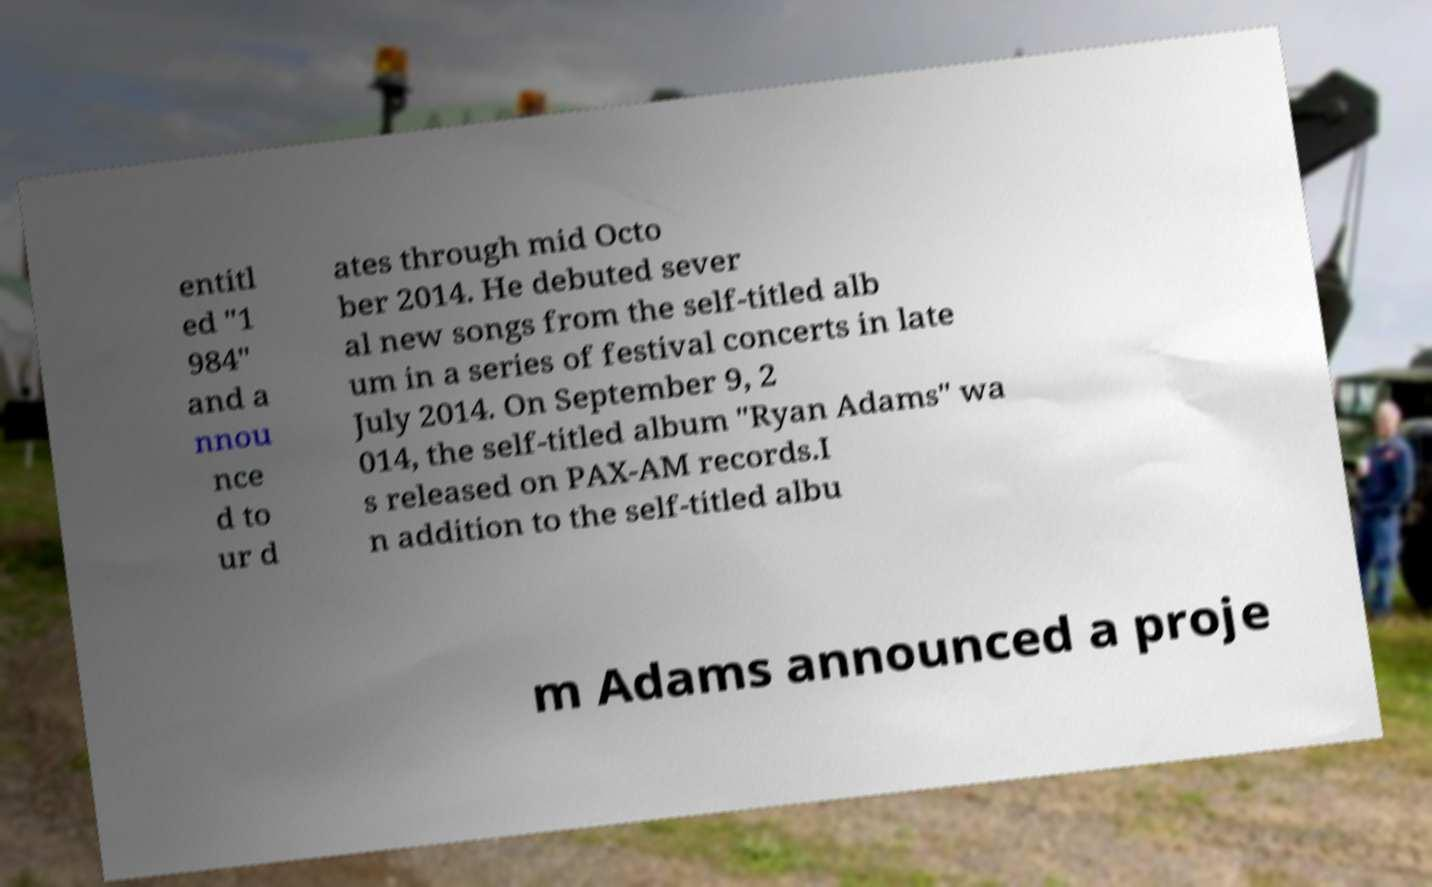Could you assist in decoding the text presented in this image and type it out clearly? entitl ed "1 984" and a nnou nce d to ur d ates through mid Octo ber 2014. He debuted sever al new songs from the self-titled alb um in a series of festival concerts in late July 2014. On September 9, 2 014, the self-titled album "Ryan Adams" wa s released on PAX-AM records.I n addition to the self-titled albu m Adams announced a proje 